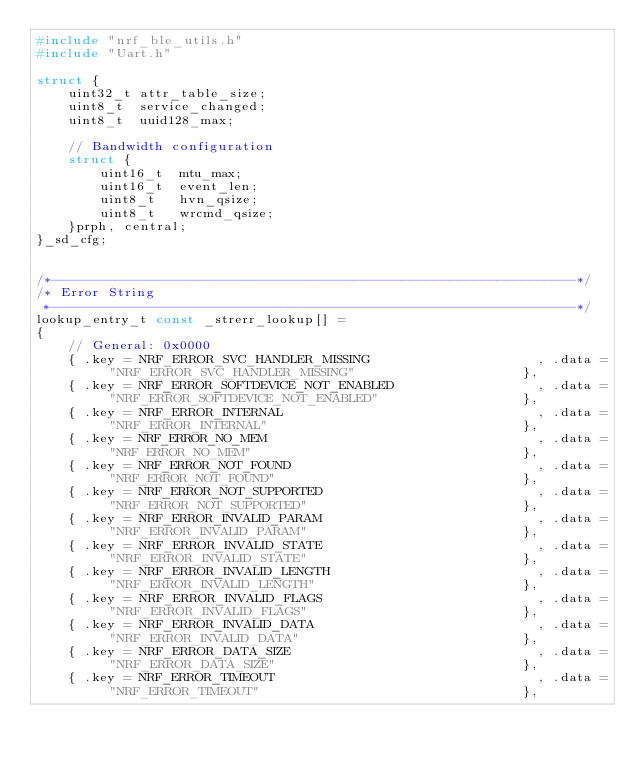Convert code to text. <code><loc_0><loc_0><loc_500><loc_500><_C++_>#include "nrf_ble_utils.h"
#include "Uart.h"

struct {
    uint32_t attr_table_size;
    uint8_t  service_changed;
    uint8_t  uuid128_max;

    // Bandwidth configuration
    struct {
        uint16_t  mtu_max;
        uint16_t  event_len;
        uint8_t   hvn_qsize;
        uint8_t   wrcmd_qsize;
    }prph, central;
}_sd_cfg;


/*------------------------------------------------------------------*/
/* Error String
 *------------------------------------------------------------------*/
lookup_entry_t const _strerr_lookup[] =
{
    // General: 0x0000
    { .key = NRF_ERROR_SVC_HANDLER_MISSING                     , .data = "NRF_ERROR_SVC_HANDLER_MISSING"                     },
    { .key = NRF_ERROR_SOFTDEVICE_NOT_ENABLED                  , .data = "NRF_ERROR_SOFTDEVICE_NOT_ENABLED"                  },
    { .key = NRF_ERROR_INTERNAL                                , .data = "NRF_ERROR_INTERNAL"                                },
    { .key = NRF_ERROR_NO_MEM                                  , .data = "NRF_ERROR_NO_MEM"                                  },
    { .key = NRF_ERROR_NOT_FOUND                               , .data = "NRF_ERROR_NOT_FOUND"                               },
    { .key = NRF_ERROR_NOT_SUPPORTED                           , .data = "NRF_ERROR_NOT_SUPPORTED"                           },
    { .key = NRF_ERROR_INVALID_PARAM                           , .data = "NRF_ERROR_INVALID_PARAM"                           },
    { .key = NRF_ERROR_INVALID_STATE                           , .data = "NRF_ERROR_INVALID_STATE"                           },
    { .key = NRF_ERROR_INVALID_LENGTH                          , .data = "NRF_ERROR_INVALID_LENGTH"                          },
    { .key = NRF_ERROR_INVALID_FLAGS                           , .data = "NRF_ERROR_INVALID_FLAGS"                           },
    { .key = NRF_ERROR_INVALID_DATA                            , .data = "NRF_ERROR_INVALID_DATA"                            },
    { .key = NRF_ERROR_DATA_SIZE                               , .data = "NRF_ERROR_DATA_SIZE"                               },
    { .key = NRF_ERROR_TIMEOUT                                 , .data = "NRF_ERROR_TIMEOUT"                                 },</code> 